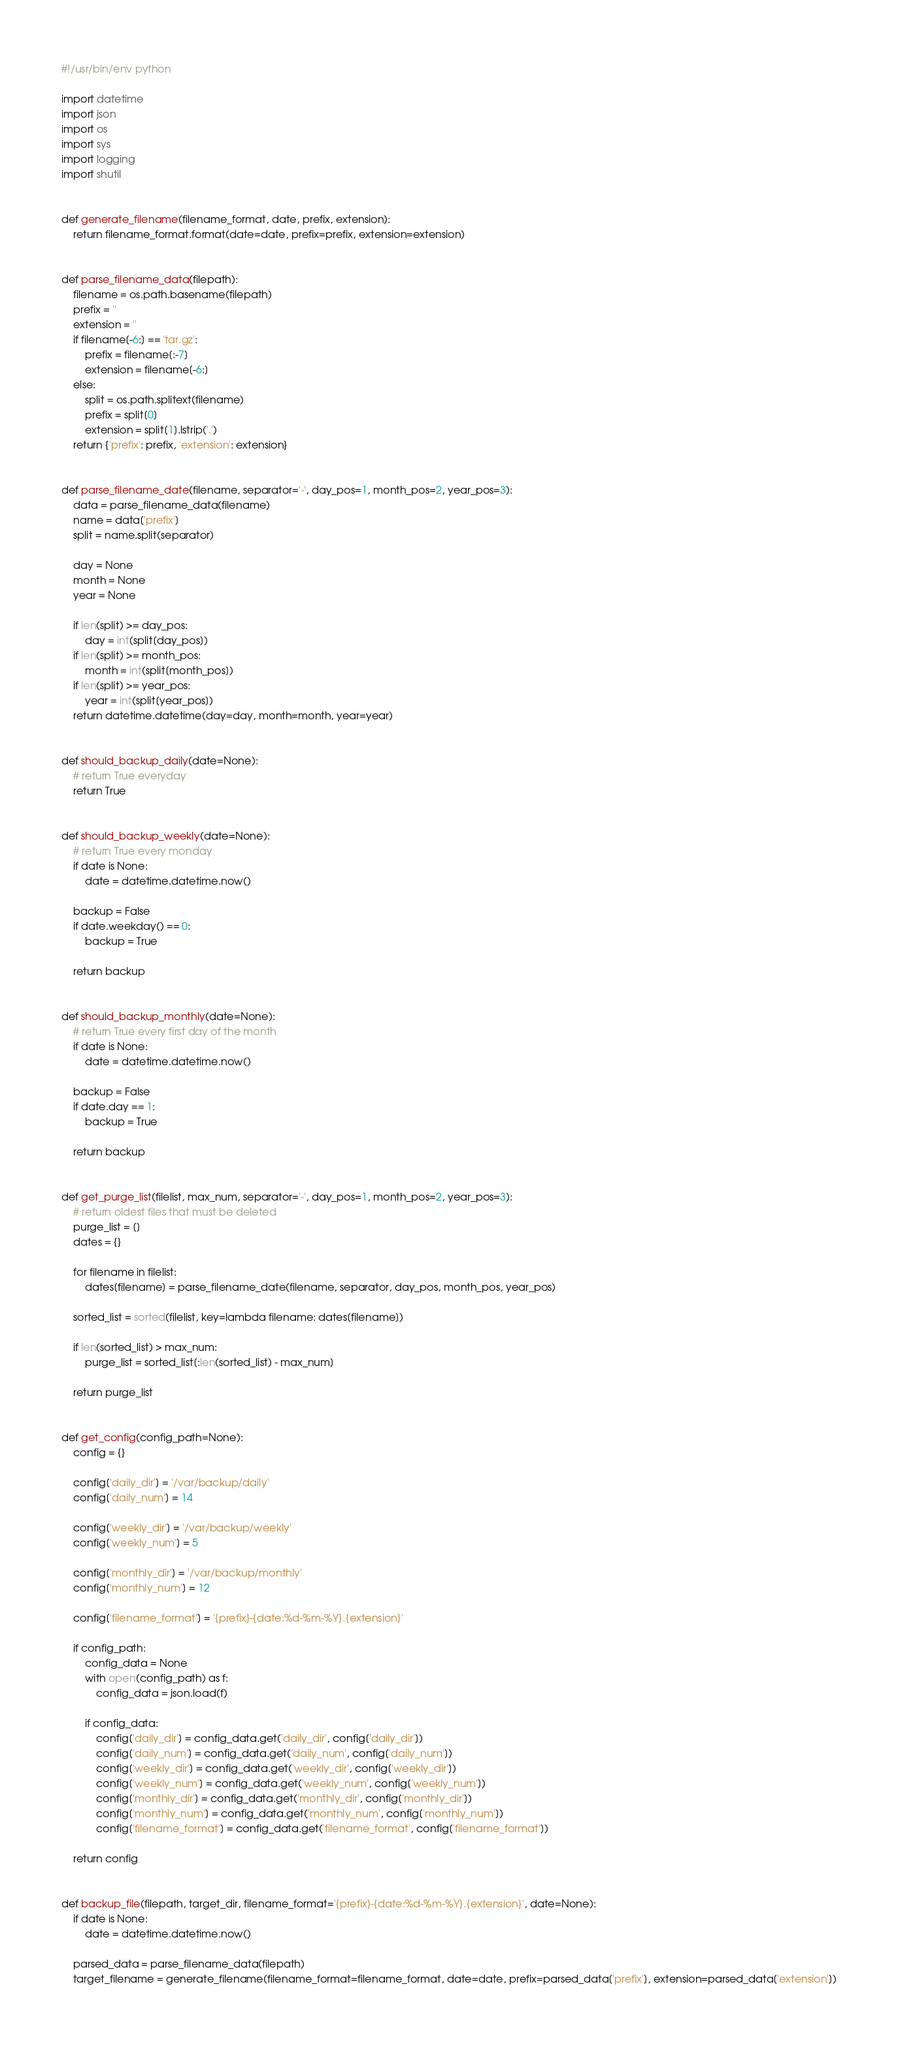Convert code to text. <code><loc_0><loc_0><loc_500><loc_500><_Python_>#!/usr/bin/env python

import datetime
import json
import os
import sys
import logging
import shutil


def generate_filename(filename_format, date, prefix, extension):
    return filename_format.format(date=date, prefix=prefix, extension=extension)


def parse_filename_data(filepath):
    filename = os.path.basename(filepath)
    prefix = ''
    extension = ''
    if filename[-6:] == 'tar.gz':
        prefix = filename[:-7]
        extension = filename[-6:]
    else:
        split = os.path.splitext(filename)
        prefix = split[0]
        extension = split[1].lstrip('.')
    return {'prefix': prefix, 'extension': extension}


def parse_filename_date(filename, separator='-', day_pos=1, month_pos=2, year_pos=3):
    data = parse_filename_data(filename)
    name = data['prefix']
    split = name.split(separator)

    day = None
    month = None
    year = None

    if len(split) >= day_pos:
        day = int(split[day_pos])
    if len(split) >= month_pos:
        month = int(split[month_pos])
    if len(split) >= year_pos:
        year = int(split[year_pos])
    return datetime.datetime(day=day, month=month, year=year)


def should_backup_daily(date=None):
    # return True everyday
    return True


def should_backup_weekly(date=None):
    # return True every monday
    if date is None:
        date = datetime.datetime.now()

    backup = False
    if date.weekday() == 0:
        backup = True

    return backup


def should_backup_monthly(date=None):
    # return True every first day of the month
    if date is None:
        date = datetime.datetime.now()

    backup = False
    if date.day == 1:
        backup = True

    return backup


def get_purge_list(filelist, max_num, separator='-', day_pos=1, month_pos=2, year_pos=3):
    # return oldest files that must be deleted
    purge_list = []
    dates = {}

    for filename in filelist:
        dates[filename] = parse_filename_date(filename, separator, day_pos, month_pos, year_pos)

    sorted_list = sorted(filelist, key=lambda filename: dates[filename])

    if len(sorted_list) > max_num:
        purge_list = sorted_list[:len(sorted_list) - max_num]

    return purge_list


def get_config(config_path=None):
    config = {}

    config['daily_dir'] = '/var/backup/daily'
    config['daily_num'] = 14

    config['weekly_dir'] = '/var/backup/weekly'
    config['weekly_num'] = 5

    config['monthly_dir'] = '/var/backup/monthly'
    config['monthly_num'] = 12

    config['filename_format'] = '{prefix}-{date:%d-%m-%Y}.{extension}'

    if config_path:
        config_data = None
        with open(config_path) as f:
            config_data = json.load(f)

        if config_data:
            config['daily_dir'] = config_data.get('daily_dir', config['daily_dir'])
            config['daily_num'] = config_data.get('daily_num', config['daily_num'])
            config['weekly_dir'] = config_data.get('weekly_dir', config['weekly_dir'])
            config['weekly_num'] = config_data.get('weekly_num', config['weekly_num'])
            config['monthly_dir'] = config_data.get('monthly_dir', config['monthly_dir'])
            config['monthly_num'] = config_data.get('monthly_num', config['monthly_num'])
            config['filename_format'] = config_data.get('filename_format', config['filename_format'])

    return config


def backup_file(filepath, target_dir, filename_format='{prefix}-{date:%d-%m-%Y}.{extension}', date=None):
    if date is None:
        date = datetime.datetime.now()

    parsed_data = parse_filename_data(filepath)
    target_filename = generate_filename(filename_format=filename_format, date=date, prefix=parsed_data['prefix'], extension=parsed_data['extension'])</code> 